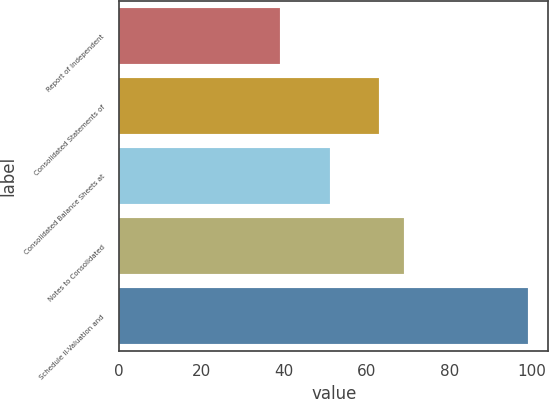Convert chart. <chart><loc_0><loc_0><loc_500><loc_500><bar_chart><fcel>Report of Independent<fcel>Consolidated Statements of<fcel>Consolidated Balance Sheets at<fcel>Notes to Consolidated<fcel>Schedule II-Valuation and<nl><fcel>39<fcel>63<fcel>51<fcel>69<fcel>99<nl></chart> 